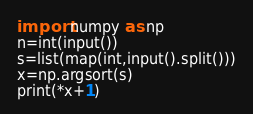Convert code to text. <code><loc_0><loc_0><loc_500><loc_500><_Python_>import numpy as np
n=int(input())
s=list(map(int,input().split()))
x=np.argsort(s)
print(*x+1)</code> 